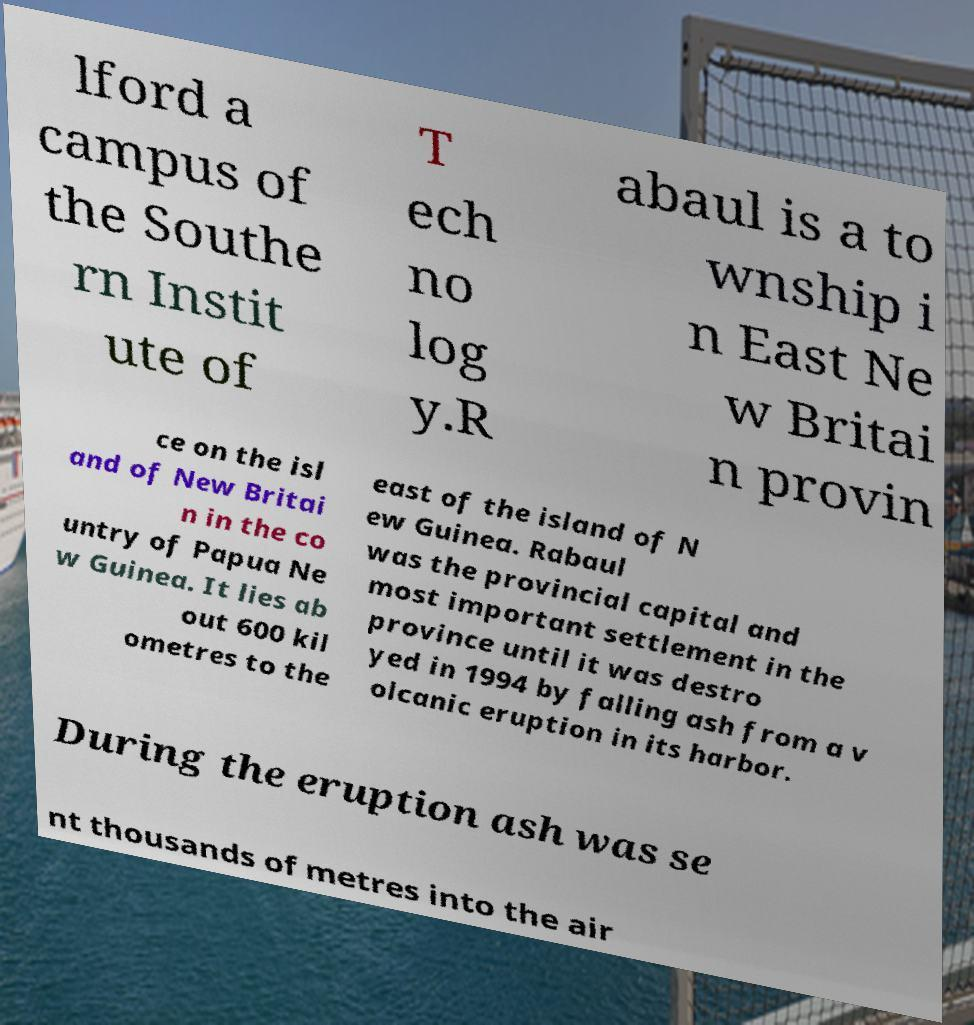Please identify and transcribe the text found in this image. lford a campus of the Southe rn Instit ute of T ech no log y.R abaul is a to wnship i n East Ne w Britai n provin ce on the isl and of New Britai n in the co untry of Papua Ne w Guinea. It lies ab out 600 kil ometres to the east of the island of N ew Guinea. Rabaul was the provincial capital and most important settlement in the province until it was destro yed in 1994 by falling ash from a v olcanic eruption in its harbor. During the eruption ash was se nt thousands of metres into the air 